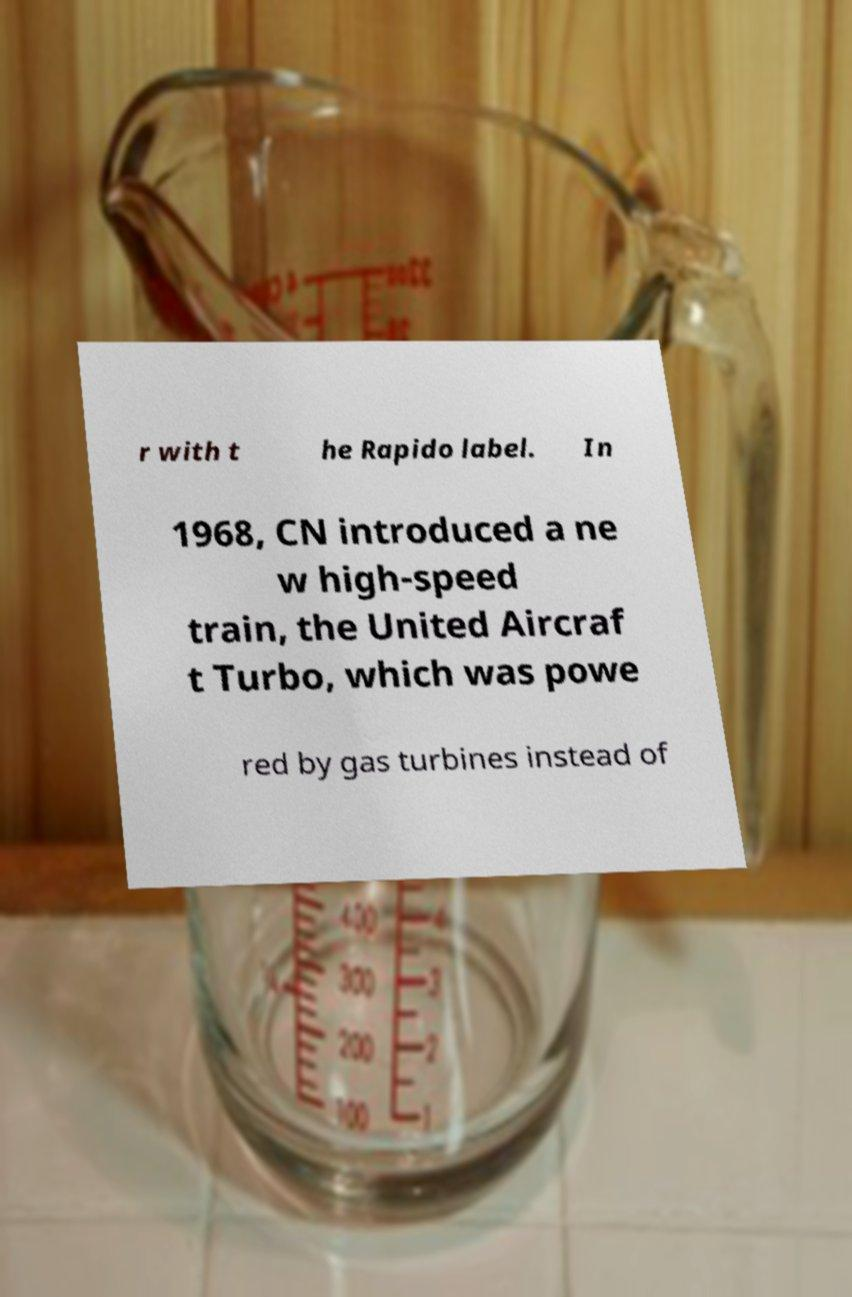What messages or text are displayed in this image? I need them in a readable, typed format. r with t he Rapido label. In 1968, CN introduced a ne w high-speed train, the United Aircraf t Turbo, which was powe red by gas turbines instead of 